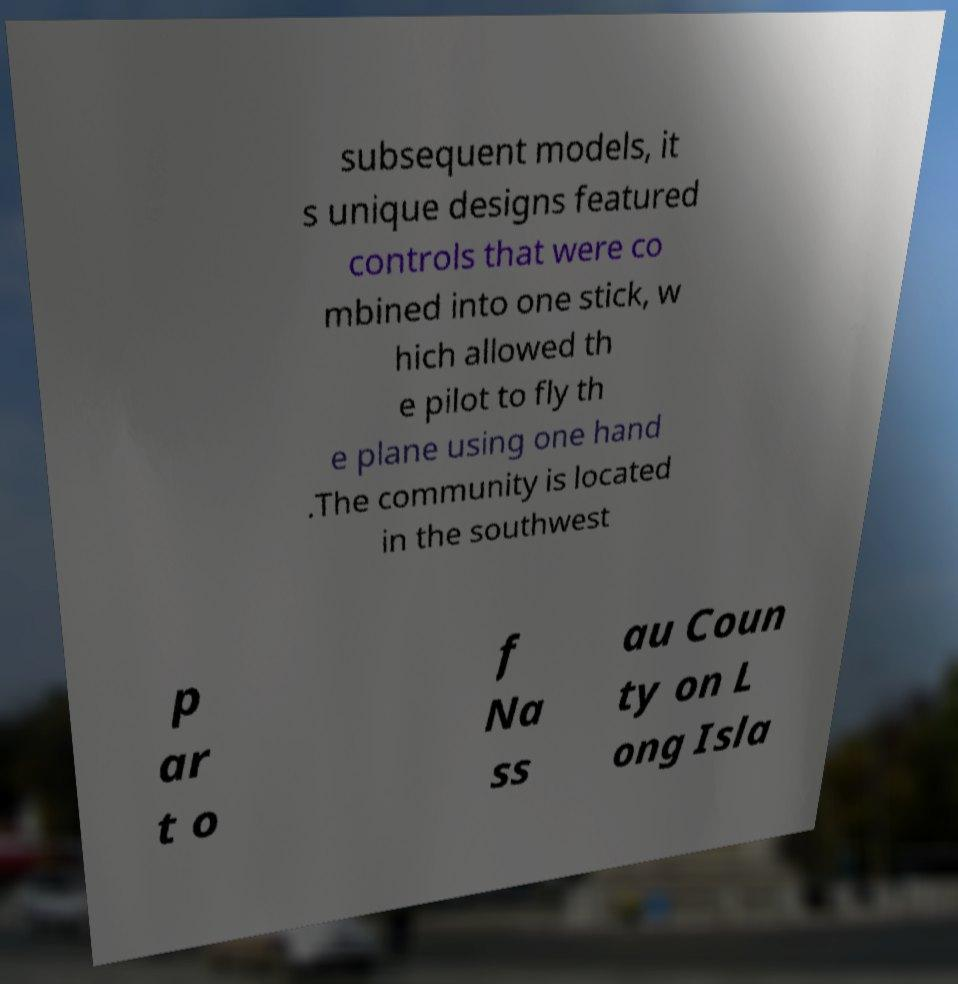Please read and relay the text visible in this image. What does it say? subsequent models, it s unique designs featured controls that were co mbined into one stick, w hich allowed th e pilot to fly th e plane using one hand .The community is located in the southwest p ar t o f Na ss au Coun ty on L ong Isla 